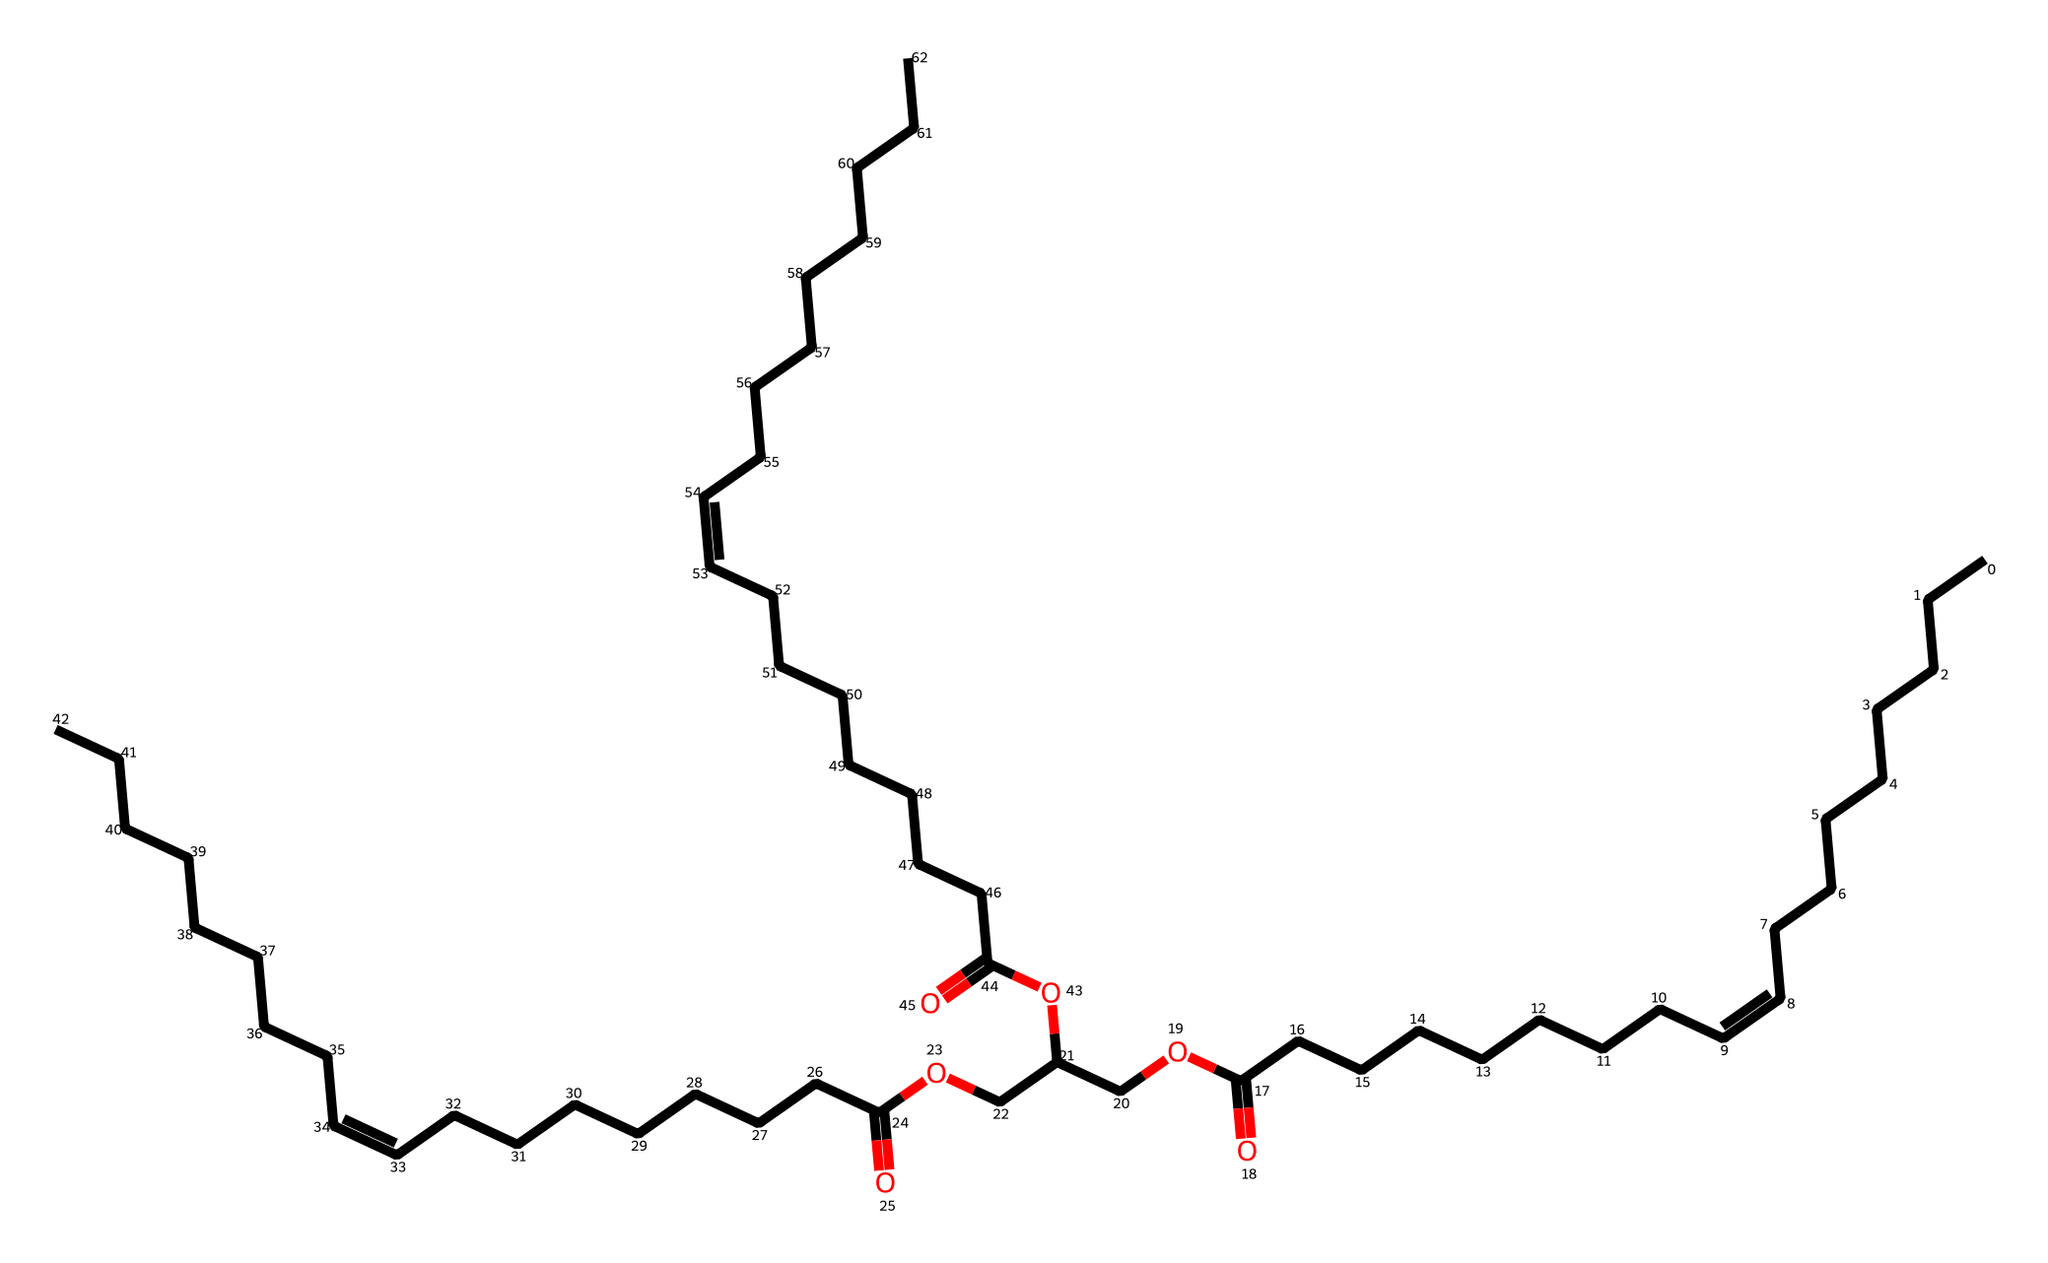How many carbon atoms are present in the structure? By analyzing the SMILES notation, we can count the number of carbon atoms (C) represented. There are 36 carbon atoms in the fatty acid chains and ester backbones.
Answer: 36 What type of functional group is present in this molecule? The molecule contains a carboxylic acid group (–COOH) and ester groups (–COO–) based on the structure indicated by the carbonyl and oxygen connections.
Answer: ester and carboxylic acid What is the degree of unsaturation in this molecule? The presence of double bonds denotes unsaturation. In the SMILES, the "/C=C\" indicates that there are 3 double bonds in the long carbon chains, suggesting partial unsaturation in the structure.
Answer: 3 Is this molecule likely to be solid or liquid at room temperature? Given its molecular structure rich in long fatty acid chains and the presence of unsaturated bonds, this substance is typically liquid at room temperature, characteristic of many vegetable oils.
Answer: liquid What role do unsaturated bonds play in the properties of this lubricant? Unsaturated bonds contribute to the fluidity and lubrication properties, allowing the lubricant to remain functional and effective at lower temperatures while reducing friction when used in sprays.
Answer: reduced friction How many ester linkages are present in this molecule? By examining the structure, we can identify the number of ester linkages formed between fatty acids and alcohols. There are 3 ester groups connecting different fatty acid chains in this structure.
Answer: 3 